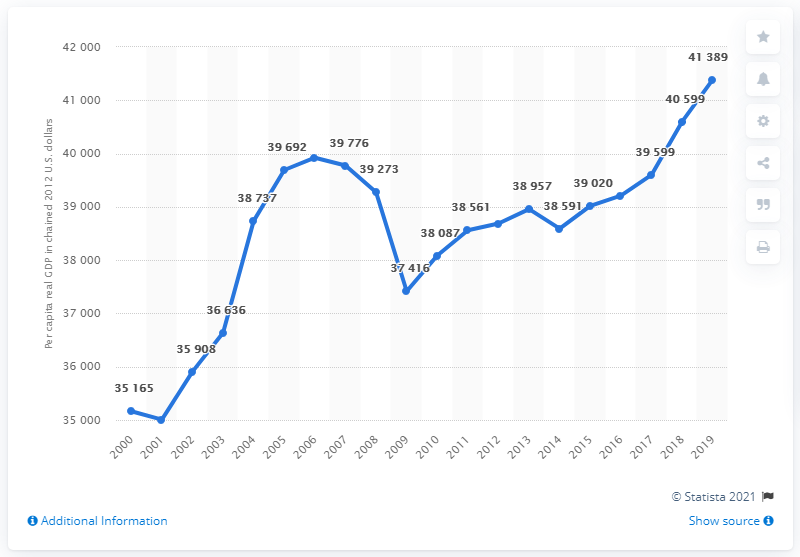Outline some significant characteristics in this image. The lowest point on this graph occurred in 2001. The average of 2017, 2018, and 2019 is approximately 40,529. 